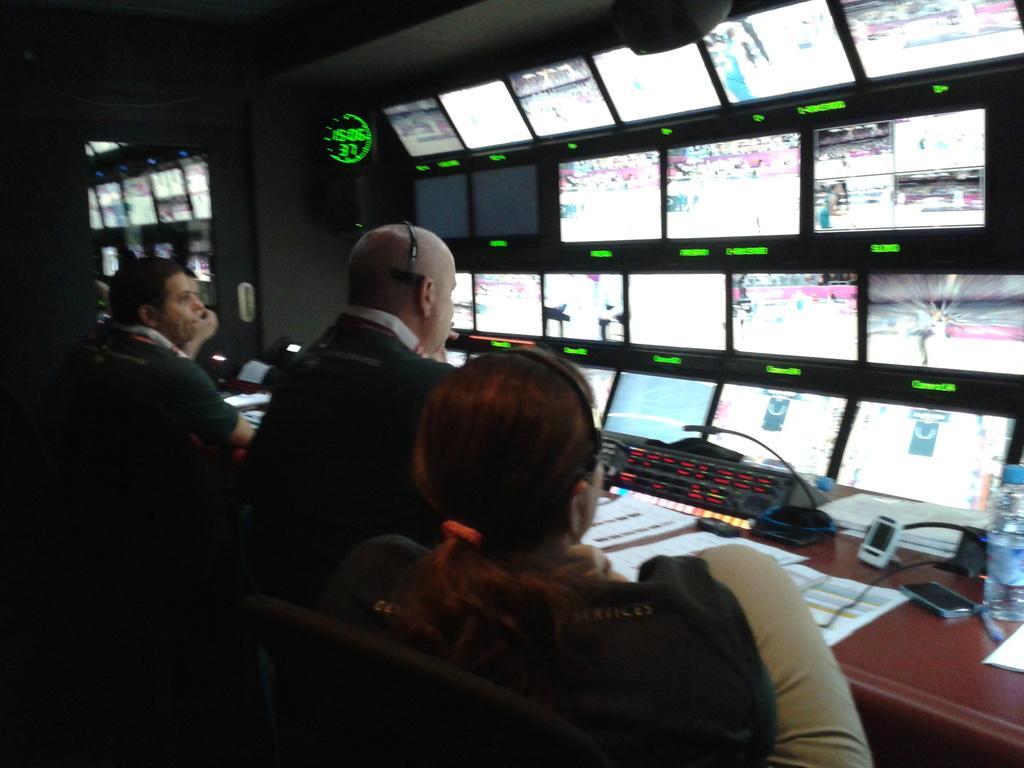Can you describe this image briefly? In this picture, we can see a few people, chairs, we can see some objects on the table like, bottles, papers, devices, and we can see some screen, and we can see the glass door. 